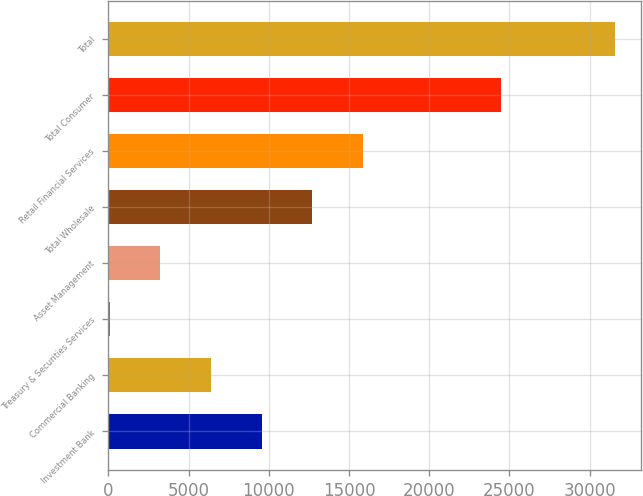<chart> <loc_0><loc_0><loc_500><loc_500><bar_chart><fcel>Investment Bank<fcel>Commercial Banking<fcel>Treasury & Securities Services<fcel>Asset Management<fcel>Total Wholesale<fcel>Retail Financial Services<fcel>Total Consumer<fcel>Total<nl><fcel>9542.2<fcel>6390.8<fcel>88<fcel>3239.4<fcel>12693.6<fcel>15845<fcel>24457<fcel>31602<nl></chart> 